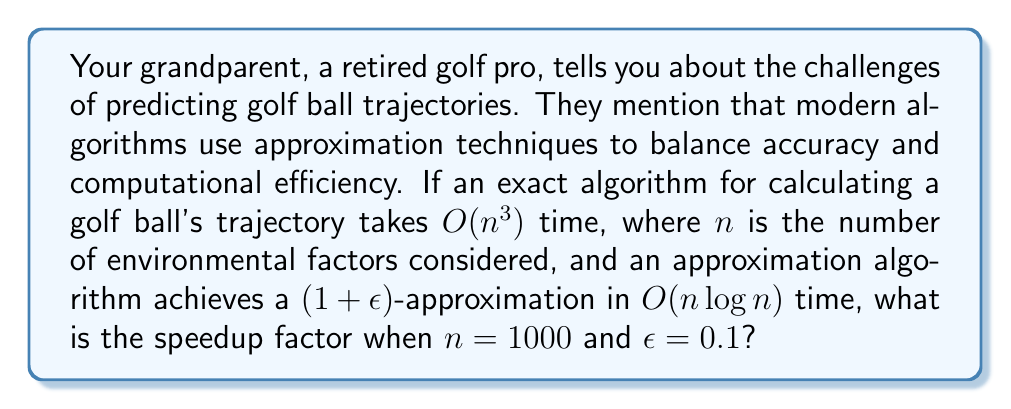Can you answer this question? To solve this problem, we need to follow these steps:

1) First, let's calculate the time complexity for the exact algorithm:
   $T_{exact} = O(n^3) = O(1000^3) = O(10^9)$

2) Now, let's calculate the time complexity for the approximation algorithm:
   $T_{approx} = O(n \log n) = O(1000 \log 1000) \approx O(1000 \cdot 10) = O(10^4)$

3) The speedup factor is the ratio of these two:
   $\text{Speedup} = \frac{T_{exact}}{T_{approx}} = \frac{O(10^9)}{O(10^4)} = O(10^5)$

4) This means the approximation algorithm is about $10^5$ times faster than the exact algorithm.

5) However, we need to consider the accuracy trade-off. The $(1+\epsilon)$-approximation means that the result is guaranteed to be within a factor of $(1+\epsilon)$ of the optimal solution. With $\epsilon=0.1$, the approximation is within 10% of the exact solution.

6) In the context of golf ball trajectories, this trade-off often provides a good balance between accuracy and computational efficiency, especially when considering real-time applications or when analyzing multiple trajectories quickly.
Answer: The speedup factor is $O(10^5)$, meaning the approximation algorithm is about 100,000 times faster than the exact algorithm, while guaranteeing a solution within 10% of the optimal. 